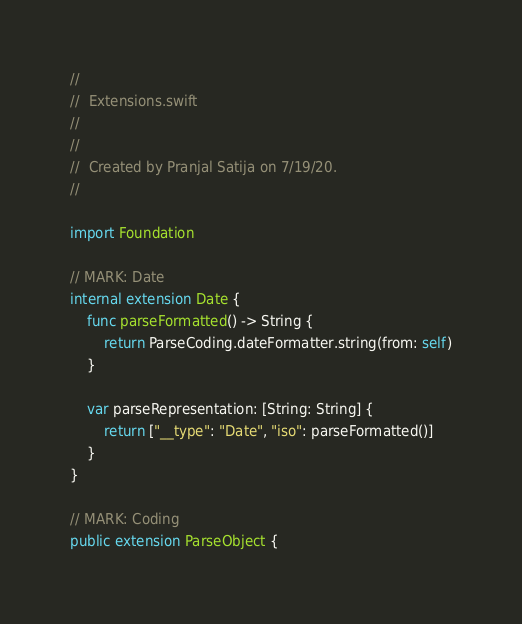Convert code to text. <code><loc_0><loc_0><loc_500><loc_500><_Swift_>//
//  Extensions.swift
//  
//
//  Created by Pranjal Satija on 7/19/20.
//

import Foundation

// MARK: Date
internal extension Date {
    func parseFormatted() -> String {
        return ParseCoding.dateFormatter.string(from: self)
    }

    var parseRepresentation: [String: String] {
        return ["__type": "Date", "iso": parseFormatted()]
    }
}

// MARK: Coding
public extension ParseObject {</code> 